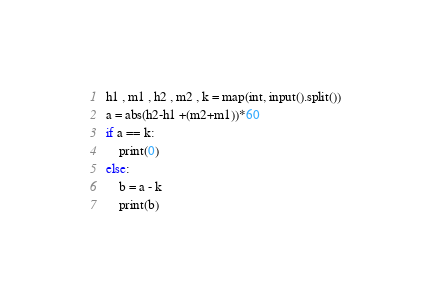<code> <loc_0><loc_0><loc_500><loc_500><_Python_>h1 , m1 , h2 , m2 , k = map(int, input().split())
a = abs(h2-h1 +(m2+m1))*60
if a == k:
    print(0)
else:
    b = a - k
    print(b)</code> 